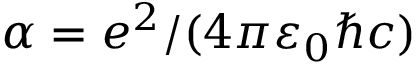<formula> <loc_0><loc_0><loc_500><loc_500>\alpha = e ^ { 2 } / ( 4 \pi \varepsilon _ { 0 } \hbar { c } )</formula> 